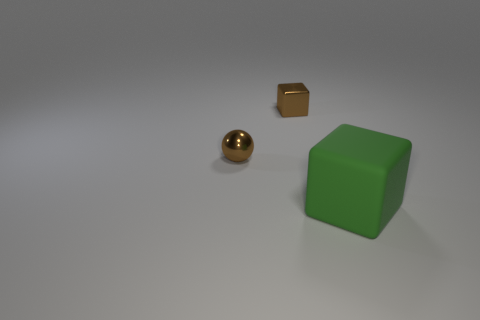Does the tiny metallic block have the same color as the shiny ball?
Provide a short and direct response. Yes. Is there any other thing that is the same size as the rubber thing?
Ensure brevity in your answer.  No. There is a thing that is in front of the small brown metal block and to the left of the large matte object; what shape is it?
Offer a very short reply. Sphere. Are the cube that is on the left side of the green matte block and the large cube made of the same material?
Your answer should be very brief. No. How many things are either small gray balls or things in front of the tiny sphere?
Offer a terse response. 1. How many small cubes have the same material as the big green cube?
Give a very brief answer. 0. What number of small brown balls are there?
Your answer should be compact. 1. There is a cube that is on the left side of the green block; is its color the same as the small thing that is in front of the brown cube?
Provide a short and direct response. Yes. There is a brown cube; what number of brown balls are to the left of it?
Ensure brevity in your answer.  1. There is a tiny sphere that is the same color as the metallic block; what is its material?
Your answer should be very brief. Metal. 